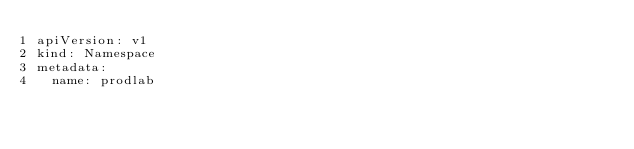<code> <loc_0><loc_0><loc_500><loc_500><_YAML_>apiVersion: v1
kind: Namespace
metadata:
  name: prodlab
</code> 